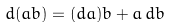<formula> <loc_0><loc_0><loc_500><loc_500>d ( a b ) = ( d a ) b + a \, d b</formula> 